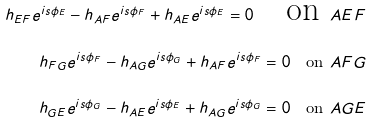<formula> <loc_0><loc_0><loc_500><loc_500>\label l { p r e - c o c y c } h _ { E F } e ^ { i s \phi _ { E } } - h _ { A F } e ^ { i s \phi _ { F } } + h _ { A E } e ^ { i s \phi _ { E } } = 0 \quad \text {on } A E F \\ h _ { F G } e ^ { i s \phi _ { F } } - h _ { A G } e ^ { i s \phi _ { G } } + h _ { A F } e ^ { i s \phi _ { F } } = 0 \quad \text {on } A F G \\ h _ { G E } e ^ { i s \phi _ { G } } - h _ { A E } e ^ { i s \phi _ { E } } + h _ { A G } e ^ { i s \phi _ { G } } = 0 \quad \text {on } A G E</formula> 